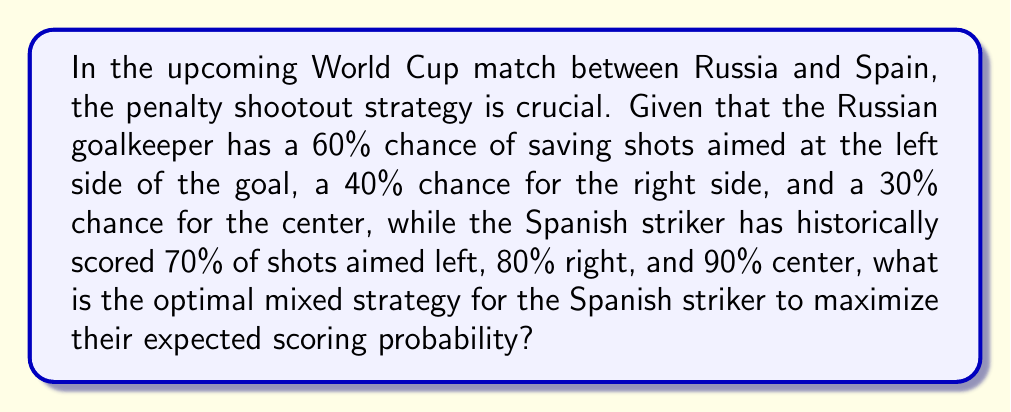What is the answer to this math problem? Let's approach this problem using game theory and the concept of mixed strategies.

1) First, we'll set up the payoff matrix for the Spanish striker:

   $$ \begin{array}{c|ccc}
      & \text{Left} & \text{Right} & \text{Center} \\
      \hline
      \text{Left} & 0.4 & 0.7 & 0.7 \\
      \text{Right} & 0.8 & 0.6 & 0.8 \\
      \text{Center} & 0.9 & 0.9 & 0.7
   \end{array} $$

   Where each cell represents the probability of scoring given the striker's choice and the goalkeeper's choice.

2) Let $x$, $y$, and $z$ be the probabilities of the striker choosing left, right, and center respectively. We know that $x + y + z = 1$.

3) For a mixed strategy to be optimal, the expected payoff for each pure strategy should be equal. Let's call this expected payoff $E$:

   $$ 0.4x + 0.7y + 0.7z = E $$
   $$ 0.8x + 0.6y + 0.8z = E $$
   $$ 0.9x + 0.9y + 0.7z = E $$

4) Subtracting the first equation from the second and third:

   $$ 0.4x - 0.1y + 0.1z = 0 $$
   $$ 0.5x + 0.2y - 0.0z = 0 $$

5) From $x + y + z = 1$ and these two equations, we can solve for $x$, $y$, and $z$:

   $$ x = \frac{1}{9} $$
   $$ y = \frac{4}{9} $$
   $$ z = \frac{4}{9} $$

6) To find the expected scoring probability, we can substitute these values into any of the equations from step 3:

   $$ E = 0.4(\frac{1}{9}) + 0.7(\frac{4}{9}) + 0.7(\frac{4}{9}) = 0.7 $$

Therefore, the optimal mixed strategy for the Spanish striker is to aim left with probability $\frac{1}{9}$, right with probability $\frac{4}{9}$, and center with probability $\frac{4}{9}$, resulting in an expected scoring probability of 0.7 or 70%.
Answer: The optimal mixed strategy for the Spanish striker is to aim left with probability $\frac{1}{9}$, right with probability $\frac{4}{9}$, and center with probability $\frac{4}{9}$. This strategy results in an expected scoring probability of 0.7 or 70%. 